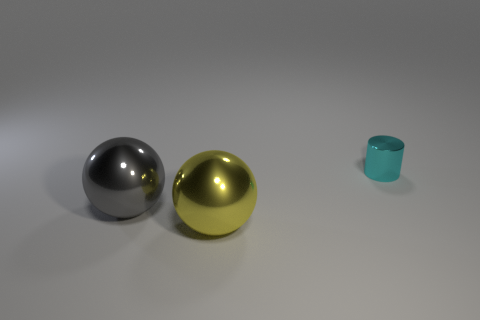Add 1 small cubes. How many objects exist? 4 Subtract all cylinders. How many objects are left? 2 Subtract all big blue rubber cylinders. Subtract all tiny metallic things. How many objects are left? 2 Add 1 gray shiny things. How many gray shiny things are left? 2 Add 1 large green cylinders. How many large green cylinders exist? 1 Subtract 0 blue spheres. How many objects are left? 3 